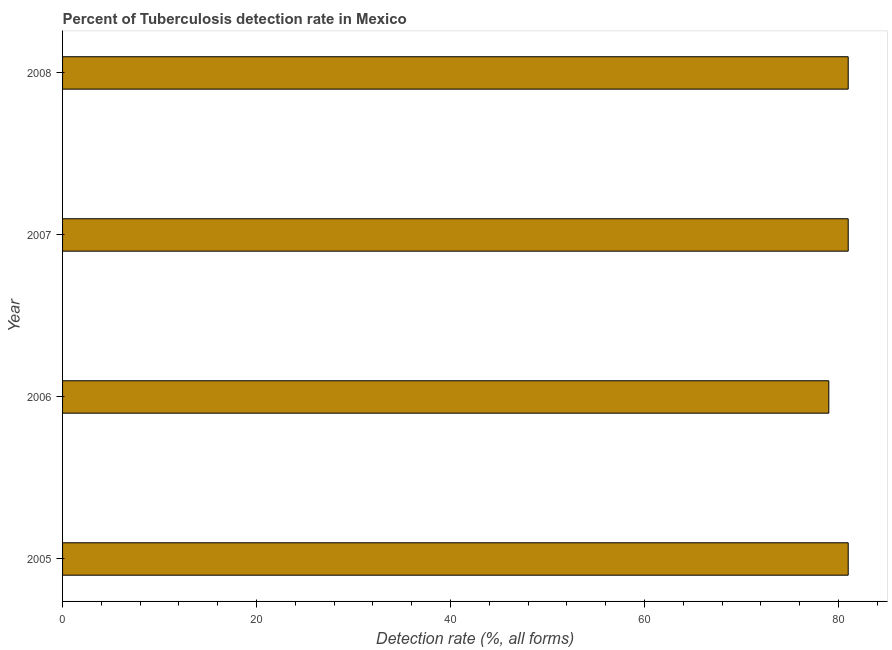What is the title of the graph?
Your response must be concise. Percent of Tuberculosis detection rate in Mexico. What is the label or title of the X-axis?
Your answer should be compact. Detection rate (%, all forms). Across all years, what is the maximum detection rate of tuberculosis?
Ensure brevity in your answer.  81. Across all years, what is the minimum detection rate of tuberculosis?
Offer a terse response. 79. In which year was the detection rate of tuberculosis maximum?
Keep it short and to the point. 2005. What is the sum of the detection rate of tuberculosis?
Offer a terse response. 322. What is the difference between the detection rate of tuberculosis in 2006 and 2007?
Your answer should be compact. -2. What is the median detection rate of tuberculosis?
Keep it short and to the point. 81. In how many years, is the detection rate of tuberculosis greater than 56 %?
Your answer should be compact. 4. Do a majority of the years between 2006 and 2007 (inclusive) have detection rate of tuberculosis greater than 48 %?
Offer a very short reply. Yes. Is the detection rate of tuberculosis in 2005 less than that in 2007?
Provide a succinct answer. No. In how many years, is the detection rate of tuberculosis greater than the average detection rate of tuberculosis taken over all years?
Give a very brief answer. 3. How many bars are there?
Make the answer very short. 4. How many years are there in the graph?
Ensure brevity in your answer.  4. What is the Detection rate (%, all forms) in 2005?
Give a very brief answer. 81. What is the Detection rate (%, all forms) in 2006?
Keep it short and to the point. 79. What is the Detection rate (%, all forms) in 2007?
Give a very brief answer. 81. What is the difference between the Detection rate (%, all forms) in 2005 and 2006?
Offer a very short reply. 2. What is the difference between the Detection rate (%, all forms) in 2005 and 2007?
Ensure brevity in your answer.  0. What is the difference between the Detection rate (%, all forms) in 2006 and 2008?
Your answer should be compact. -2. What is the ratio of the Detection rate (%, all forms) in 2005 to that in 2006?
Offer a terse response. 1.02. What is the ratio of the Detection rate (%, all forms) in 2005 to that in 2008?
Your answer should be very brief. 1. What is the ratio of the Detection rate (%, all forms) in 2006 to that in 2007?
Provide a succinct answer. 0.97. 